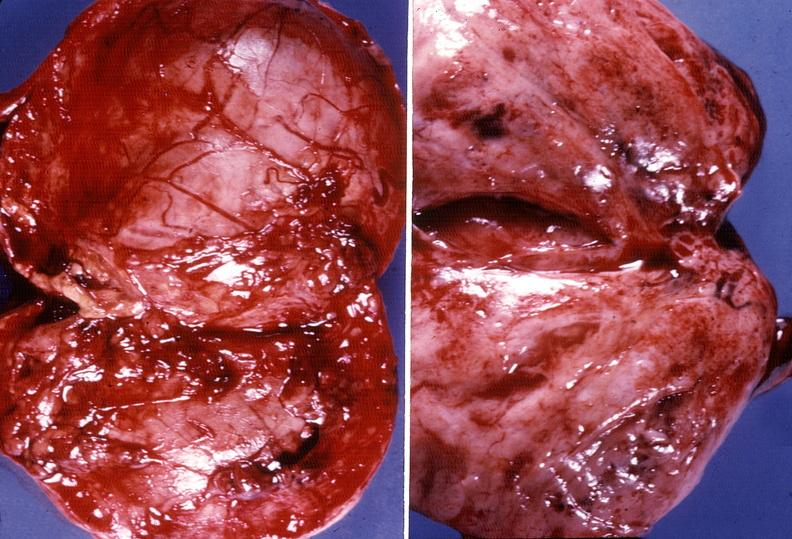where does this belong to?
Answer the question using a single word or phrase. Endocrine system 